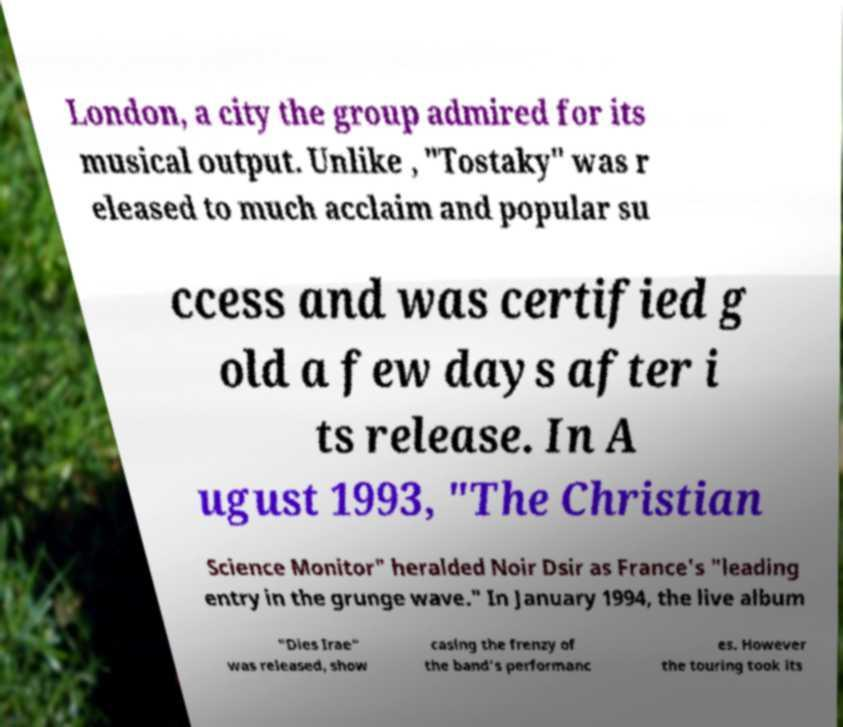Can you read and provide the text displayed in the image?This photo seems to have some interesting text. Can you extract and type it out for me? London, a city the group admired for its musical output. Unlike , "Tostaky" was r eleased to much acclaim and popular su ccess and was certified g old a few days after i ts release. In A ugust 1993, "The Christian Science Monitor" heralded Noir Dsir as France's "leading entry in the grunge wave." In January 1994, the live album "Dies Irae" was released, show casing the frenzy of the band's performanc es. However the touring took its 